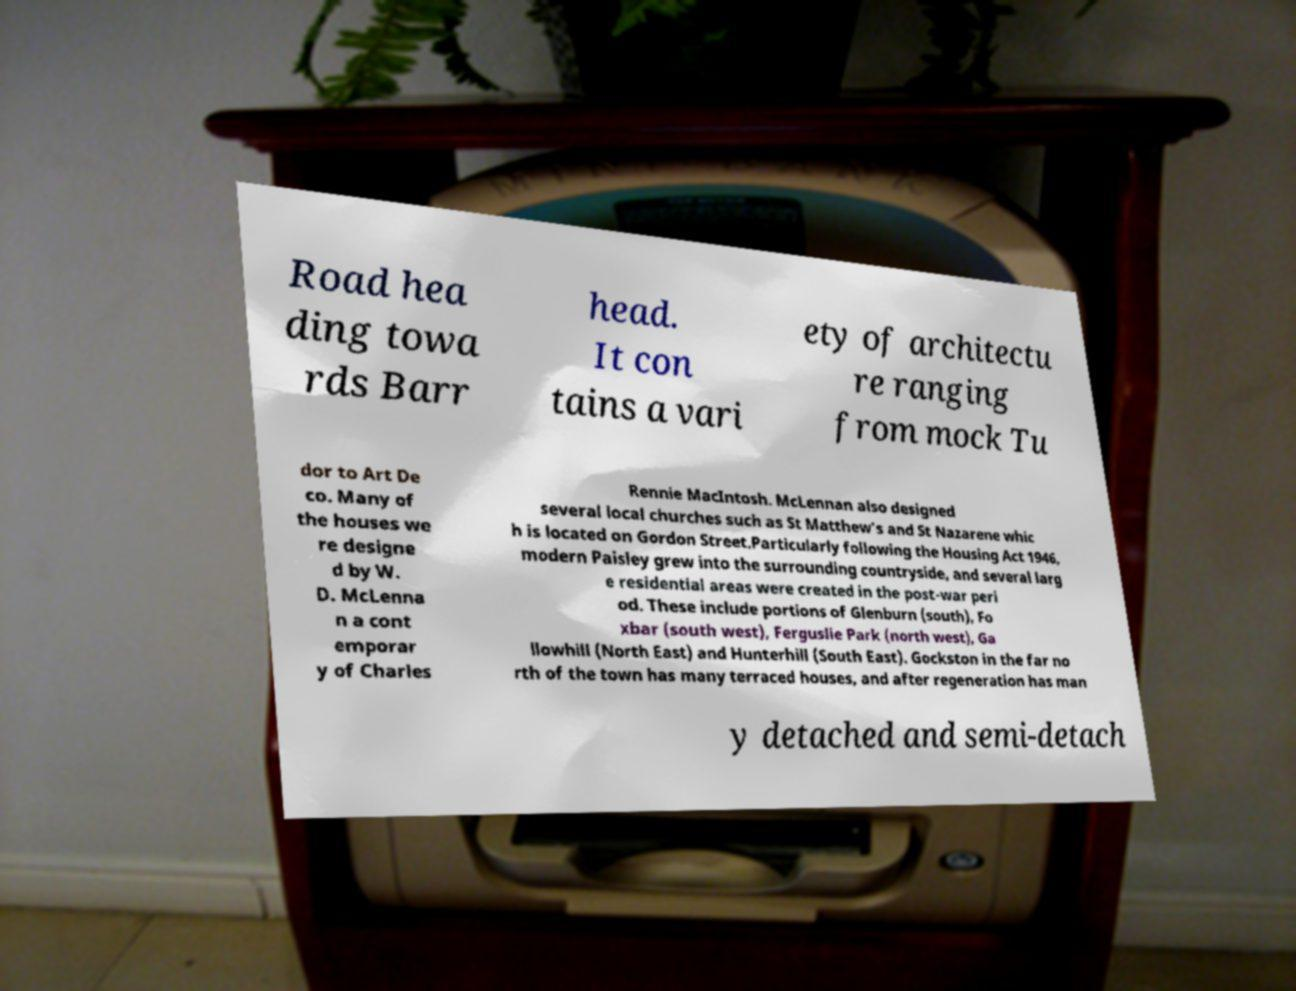Can you accurately transcribe the text from the provided image for me? Road hea ding towa rds Barr head. It con tains a vari ety of architectu re ranging from mock Tu dor to Art De co. Many of the houses we re designe d by W. D. McLenna n a cont emporar y of Charles Rennie MacIntosh. McLennan also designed several local churches such as St Matthew's and St Nazarene whic h is located on Gordon Street.Particularly following the Housing Act 1946, modern Paisley grew into the surrounding countryside, and several larg e residential areas were created in the post-war peri od. These include portions of Glenburn (south), Fo xbar (south west), Ferguslie Park (north west), Ga llowhill (North East) and Hunterhill (South East). Gockston in the far no rth of the town has many terraced houses, and after regeneration has man y detached and semi-detach 